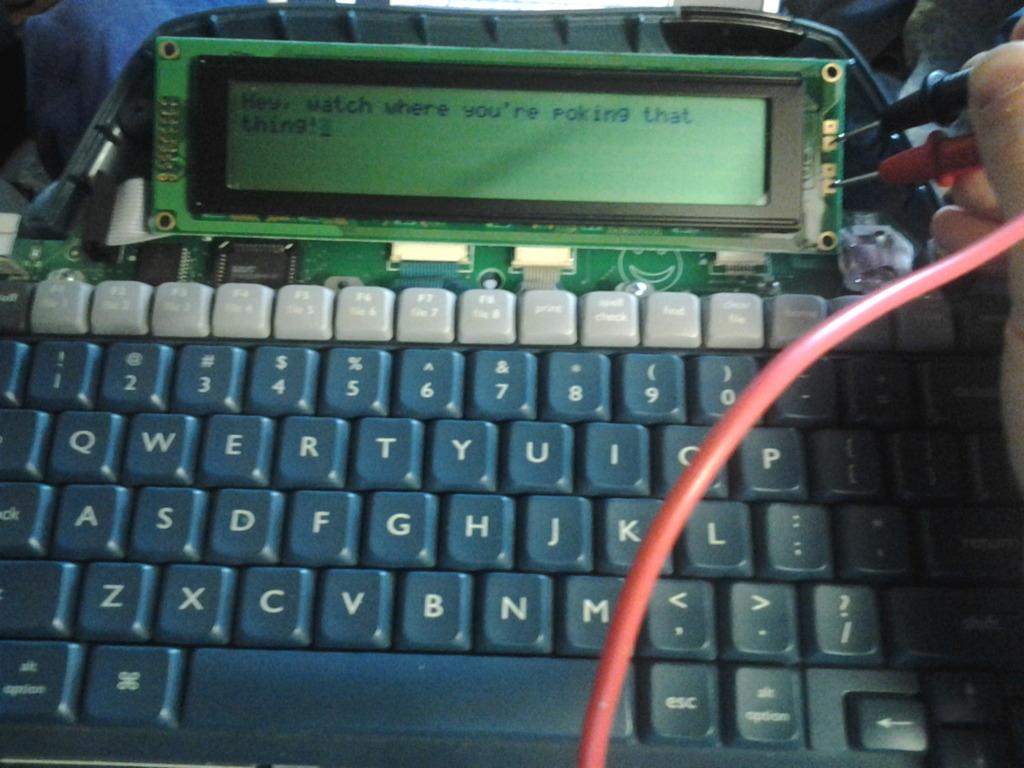What is displayed?
Offer a terse response. Hey, watch where you're poking that thing!. 